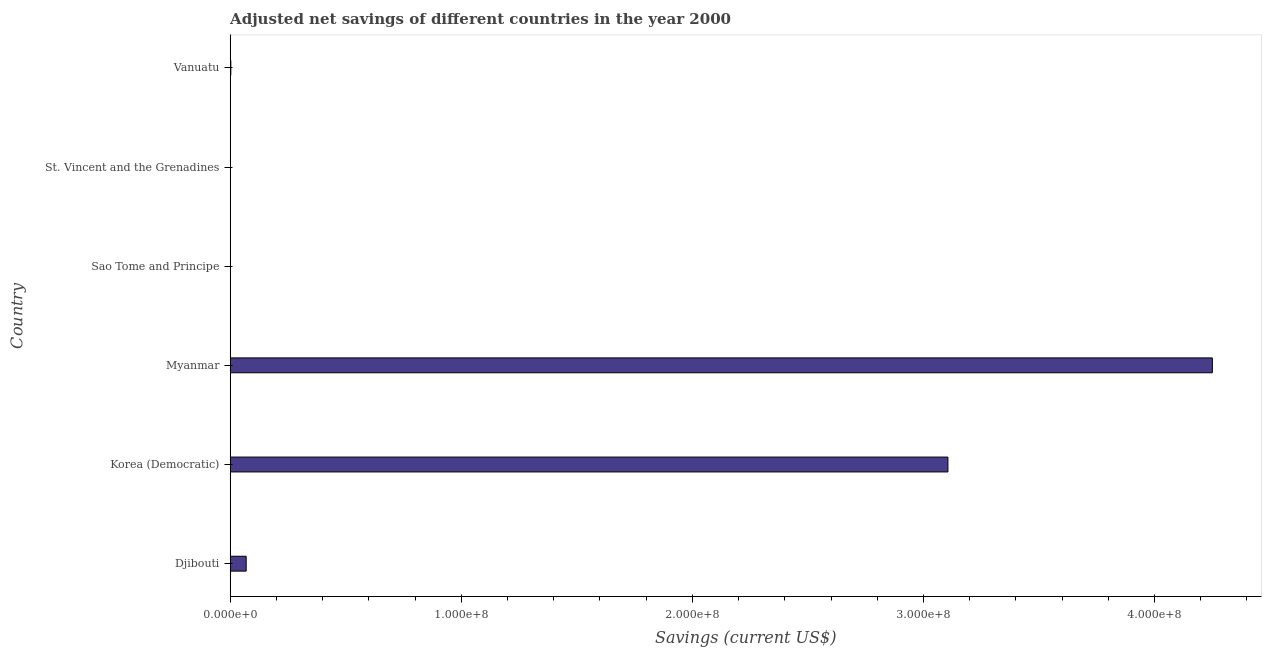Does the graph contain any zero values?
Give a very brief answer. No. What is the title of the graph?
Provide a succinct answer. Adjusted net savings of different countries in the year 2000. What is the label or title of the X-axis?
Ensure brevity in your answer.  Savings (current US$). What is the label or title of the Y-axis?
Your response must be concise. Country. What is the adjusted net savings in Vanuatu?
Offer a very short reply. 2.76e+05. Across all countries, what is the maximum adjusted net savings?
Your answer should be compact. 4.25e+08. Across all countries, what is the minimum adjusted net savings?
Provide a succinct answer. 1901.31. In which country was the adjusted net savings maximum?
Your answer should be very brief. Myanmar. In which country was the adjusted net savings minimum?
Your answer should be compact. Sao Tome and Principe. What is the sum of the adjusted net savings?
Ensure brevity in your answer.  7.43e+08. What is the difference between the adjusted net savings in Djibouti and Myanmar?
Make the answer very short. -4.18e+08. What is the average adjusted net savings per country?
Offer a terse response. 1.24e+08. What is the median adjusted net savings?
Ensure brevity in your answer.  3.60e+06. In how many countries, is the adjusted net savings greater than 320000000 US$?
Offer a terse response. 1. What is the ratio of the adjusted net savings in Djibouti to that in St. Vincent and the Grenadines?
Keep it short and to the point. 138.59. Is the difference between the adjusted net savings in Korea (Democratic) and Myanmar greater than the difference between any two countries?
Your answer should be compact. No. What is the difference between the highest and the second highest adjusted net savings?
Your response must be concise. 1.14e+08. Is the sum of the adjusted net savings in Myanmar and Vanuatu greater than the maximum adjusted net savings across all countries?
Make the answer very short. Yes. What is the difference between the highest and the lowest adjusted net savings?
Provide a succinct answer. 4.25e+08. In how many countries, is the adjusted net savings greater than the average adjusted net savings taken over all countries?
Provide a succinct answer. 2. How many bars are there?
Offer a very short reply. 6. Are the values on the major ticks of X-axis written in scientific E-notation?
Offer a very short reply. Yes. What is the Savings (current US$) of Djibouti?
Give a very brief answer. 6.92e+06. What is the Savings (current US$) of Korea (Democratic)?
Your response must be concise. 3.11e+08. What is the Savings (current US$) in Myanmar?
Keep it short and to the point. 4.25e+08. What is the Savings (current US$) of Sao Tome and Principe?
Offer a terse response. 1901.31. What is the Savings (current US$) of St. Vincent and the Grenadines?
Provide a succinct answer. 4.99e+04. What is the Savings (current US$) of Vanuatu?
Keep it short and to the point. 2.76e+05. What is the difference between the Savings (current US$) in Djibouti and Korea (Democratic)?
Give a very brief answer. -3.04e+08. What is the difference between the Savings (current US$) in Djibouti and Myanmar?
Your response must be concise. -4.18e+08. What is the difference between the Savings (current US$) in Djibouti and Sao Tome and Principe?
Give a very brief answer. 6.92e+06. What is the difference between the Savings (current US$) in Djibouti and St. Vincent and the Grenadines?
Ensure brevity in your answer.  6.87e+06. What is the difference between the Savings (current US$) in Djibouti and Vanuatu?
Provide a succinct answer. 6.65e+06. What is the difference between the Savings (current US$) in Korea (Democratic) and Myanmar?
Your answer should be compact. -1.14e+08. What is the difference between the Savings (current US$) in Korea (Democratic) and Sao Tome and Principe?
Offer a very short reply. 3.11e+08. What is the difference between the Savings (current US$) in Korea (Democratic) and St. Vincent and the Grenadines?
Offer a terse response. 3.11e+08. What is the difference between the Savings (current US$) in Korea (Democratic) and Vanuatu?
Your answer should be compact. 3.10e+08. What is the difference between the Savings (current US$) in Myanmar and Sao Tome and Principe?
Offer a very short reply. 4.25e+08. What is the difference between the Savings (current US$) in Myanmar and St. Vincent and the Grenadines?
Your answer should be compact. 4.25e+08. What is the difference between the Savings (current US$) in Myanmar and Vanuatu?
Make the answer very short. 4.25e+08. What is the difference between the Savings (current US$) in Sao Tome and Principe and St. Vincent and the Grenadines?
Provide a succinct answer. -4.80e+04. What is the difference between the Savings (current US$) in Sao Tome and Principe and Vanuatu?
Make the answer very short. -2.74e+05. What is the difference between the Savings (current US$) in St. Vincent and the Grenadines and Vanuatu?
Ensure brevity in your answer.  -2.26e+05. What is the ratio of the Savings (current US$) in Djibouti to that in Korea (Democratic)?
Make the answer very short. 0.02. What is the ratio of the Savings (current US$) in Djibouti to that in Myanmar?
Offer a very short reply. 0.02. What is the ratio of the Savings (current US$) in Djibouti to that in Sao Tome and Principe?
Offer a very short reply. 3640.19. What is the ratio of the Savings (current US$) in Djibouti to that in St. Vincent and the Grenadines?
Offer a terse response. 138.59. What is the ratio of the Savings (current US$) in Djibouti to that in Vanuatu?
Provide a succinct answer. 25.11. What is the ratio of the Savings (current US$) in Korea (Democratic) to that in Myanmar?
Offer a very short reply. 0.73. What is the ratio of the Savings (current US$) in Korea (Democratic) to that in Sao Tome and Principe?
Your response must be concise. 1.63e+05. What is the ratio of the Savings (current US$) in Korea (Democratic) to that in St. Vincent and the Grenadines?
Your response must be concise. 6219.3. What is the ratio of the Savings (current US$) in Korea (Democratic) to that in Vanuatu?
Make the answer very short. 1126.72. What is the ratio of the Savings (current US$) in Myanmar to that in Sao Tome and Principe?
Offer a very short reply. 2.24e+05. What is the ratio of the Savings (current US$) in Myanmar to that in St. Vincent and the Grenadines?
Provide a succinct answer. 8510.88. What is the ratio of the Savings (current US$) in Myanmar to that in Vanuatu?
Your answer should be very brief. 1541.88. What is the ratio of the Savings (current US$) in Sao Tome and Principe to that in St. Vincent and the Grenadines?
Keep it short and to the point. 0.04. What is the ratio of the Savings (current US$) in Sao Tome and Principe to that in Vanuatu?
Make the answer very short. 0.01. What is the ratio of the Savings (current US$) in St. Vincent and the Grenadines to that in Vanuatu?
Offer a terse response. 0.18. 